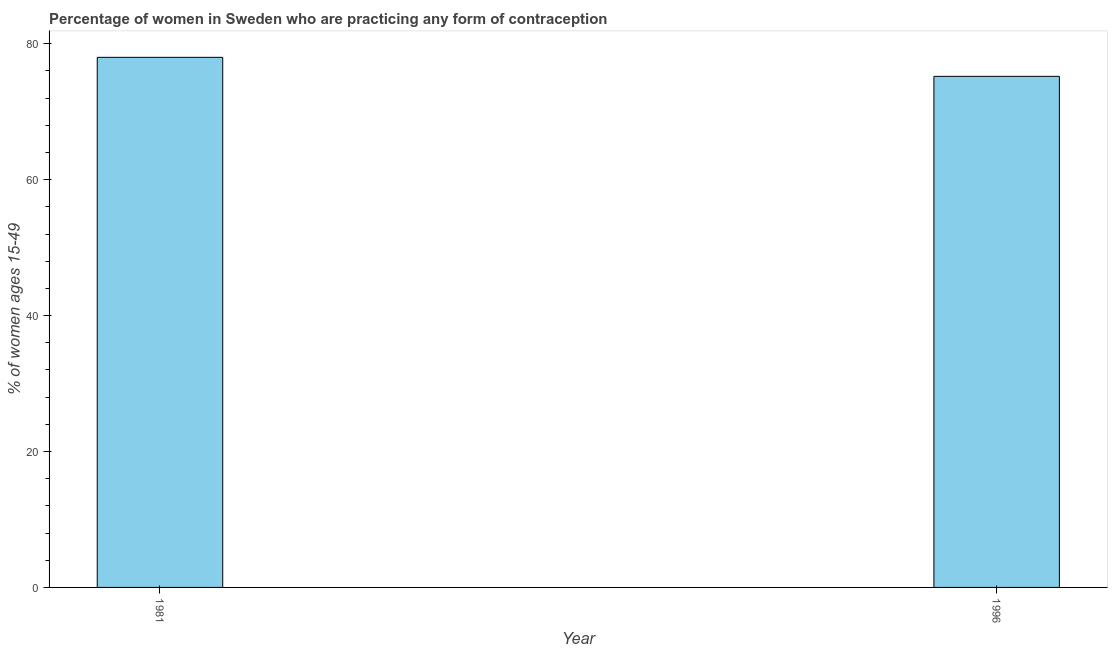What is the title of the graph?
Your answer should be compact. Percentage of women in Sweden who are practicing any form of contraception. What is the label or title of the X-axis?
Provide a short and direct response. Year. What is the label or title of the Y-axis?
Give a very brief answer. % of women ages 15-49. What is the contraceptive prevalence in 1996?
Make the answer very short. 75.2. Across all years, what is the maximum contraceptive prevalence?
Give a very brief answer. 78. Across all years, what is the minimum contraceptive prevalence?
Your answer should be very brief. 75.2. In which year was the contraceptive prevalence minimum?
Your answer should be compact. 1996. What is the sum of the contraceptive prevalence?
Your answer should be compact. 153.2. What is the average contraceptive prevalence per year?
Your answer should be very brief. 76.6. What is the median contraceptive prevalence?
Offer a very short reply. 76.6. In how many years, is the contraceptive prevalence greater than 36 %?
Ensure brevity in your answer.  2. Do a majority of the years between 1981 and 1996 (inclusive) have contraceptive prevalence greater than 68 %?
Offer a terse response. Yes. In how many years, is the contraceptive prevalence greater than the average contraceptive prevalence taken over all years?
Your response must be concise. 1. Are all the bars in the graph horizontal?
Offer a very short reply. No. What is the difference between two consecutive major ticks on the Y-axis?
Give a very brief answer. 20. Are the values on the major ticks of Y-axis written in scientific E-notation?
Make the answer very short. No. What is the % of women ages 15-49 of 1996?
Offer a very short reply. 75.2. What is the difference between the % of women ages 15-49 in 1981 and 1996?
Keep it short and to the point. 2.8. 